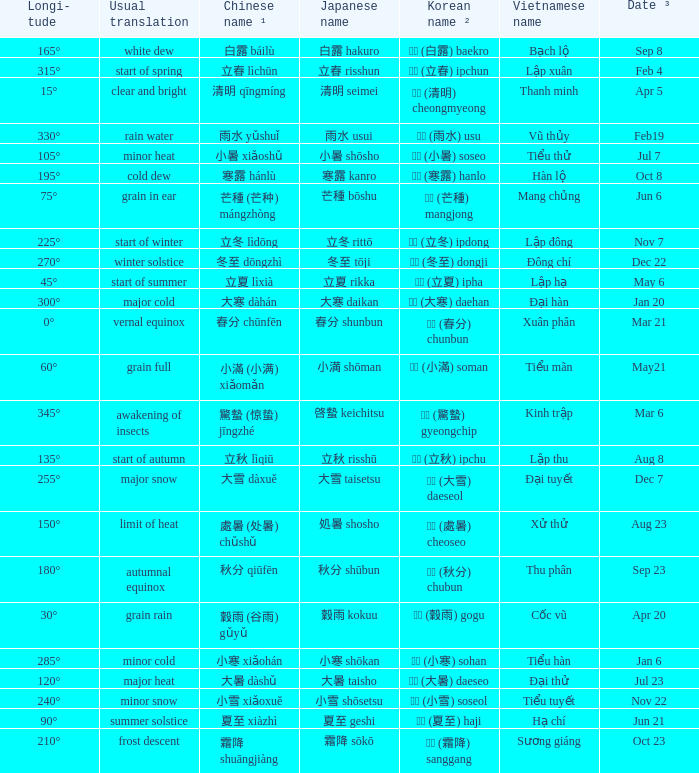Which Japanese name has a Korean name ² of 경칩 (驚蟄) gyeongchip? 啓蟄 keichitsu. 